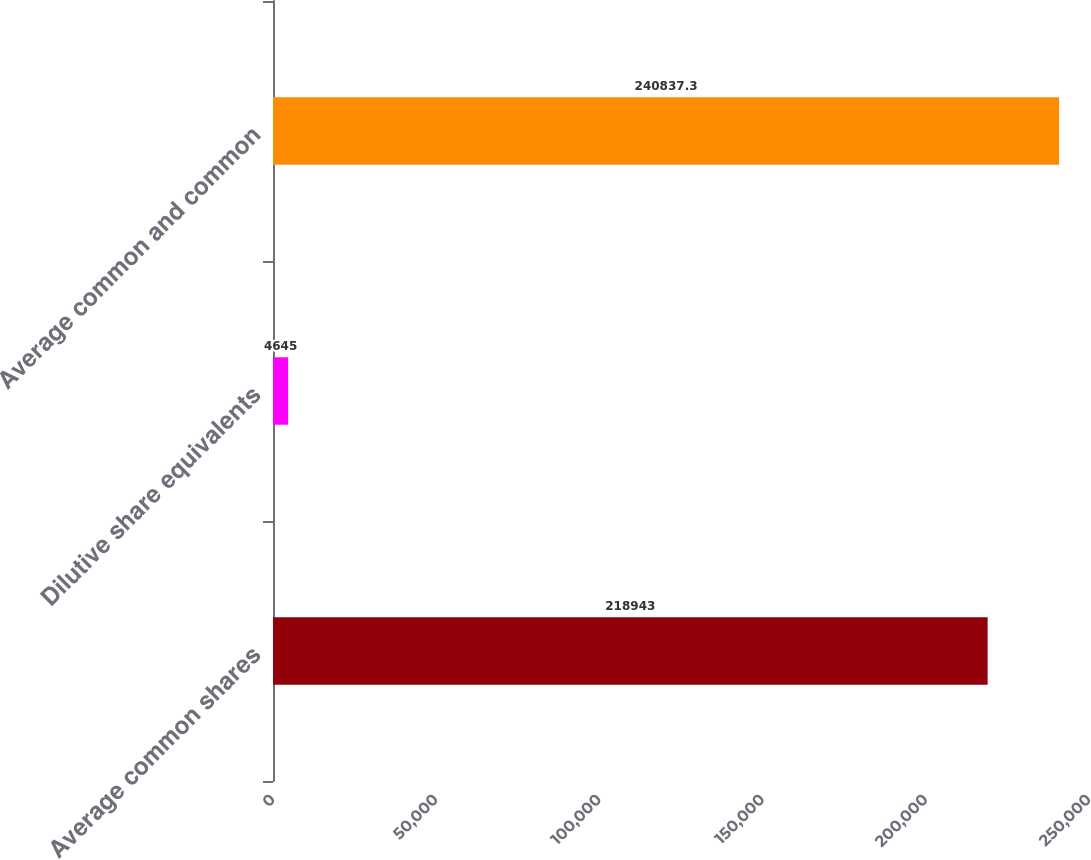<chart> <loc_0><loc_0><loc_500><loc_500><bar_chart><fcel>Average common shares<fcel>Dilutive share equivalents<fcel>Average common and common<nl><fcel>218943<fcel>4645<fcel>240837<nl></chart> 